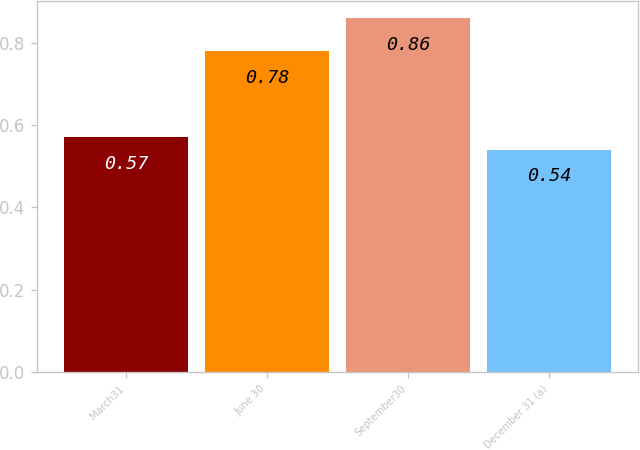Convert chart. <chart><loc_0><loc_0><loc_500><loc_500><bar_chart><fcel>March31<fcel>June 30<fcel>September30<fcel>December 31 (a)<nl><fcel>0.57<fcel>0.78<fcel>0.86<fcel>0.54<nl></chart> 